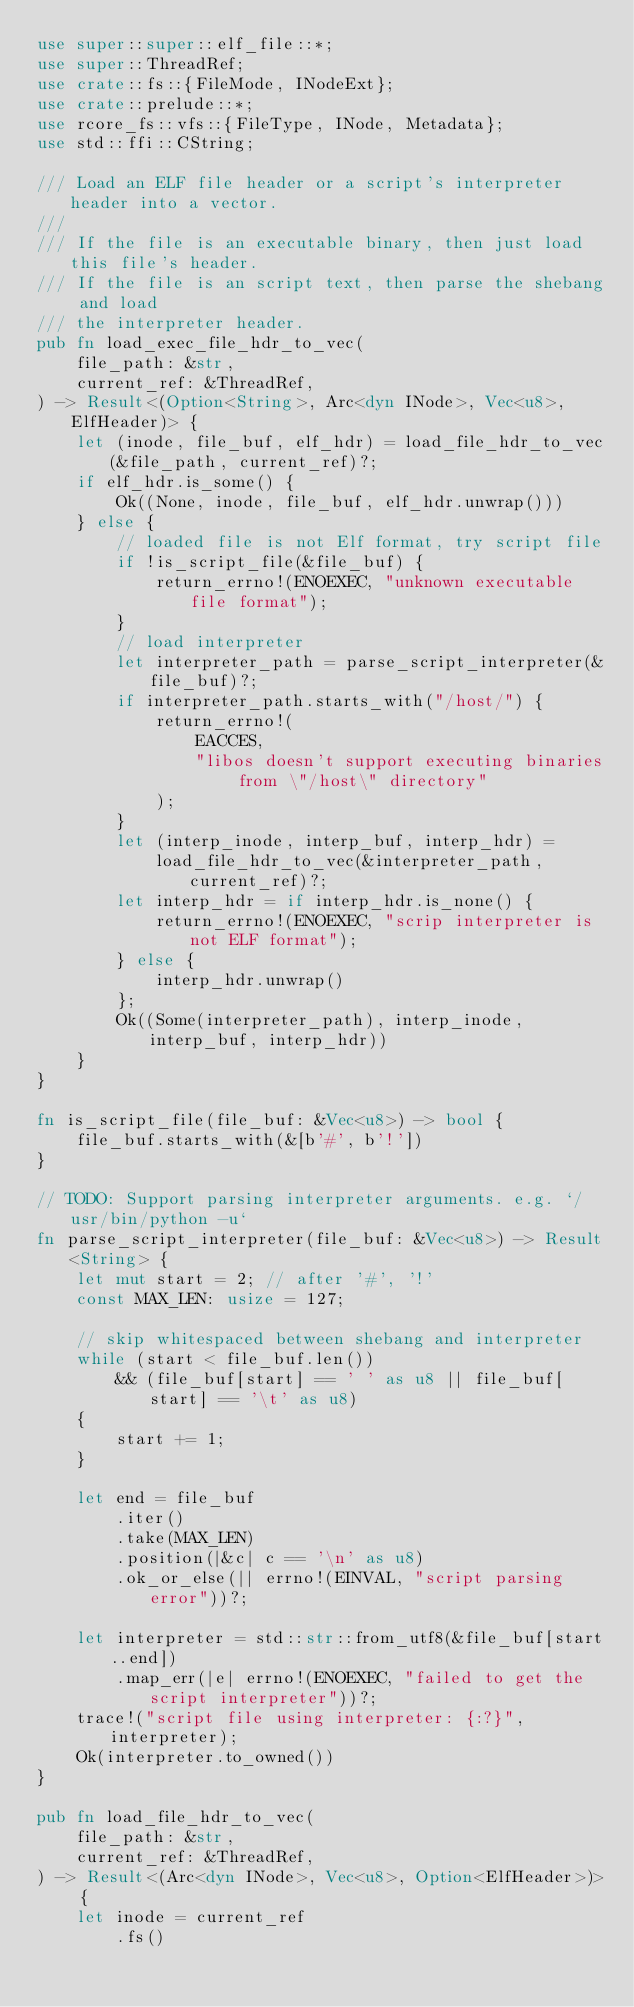Convert code to text. <code><loc_0><loc_0><loc_500><loc_500><_Rust_>use super::super::elf_file::*;
use super::ThreadRef;
use crate::fs::{FileMode, INodeExt};
use crate::prelude::*;
use rcore_fs::vfs::{FileType, INode, Metadata};
use std::ffi::CString;

/// Load an ELF file header or a script's interpreter header into a vector.
///
/// If the file is an executable binary, then just load this file's header.
/// If the file is an script text, then parse the shebang and load
/// the interpreter header.
pub fn load_exec_file_hdr_to_vec(
    file_path: &str,
    current_ref: &ThreadRef,
) -> Result<(Option<String>, Arc<dyn INode>, Vec<u8>, ElfHeader)> {
    let (inode, file_buf, elf_hdr) = load_file_hdr_to_vec(&file_path, current_ref)?;
    if elf_hdr.is_some() {
        Ok((None, inode, file_buf, elf_hdr.unwrap()))
    } else {
        // loaded file is not Elf format, try script file
        if !is_script_file(&file_buf) {
            return_errno!(ENOEXEC, "unknown executable file format");
        }
        // load interpreter
        let interpreter_path = parse_script_interpreter(&file_buf)?;
        if interpreter_path.starts_with("/host/") {
            return_errno!(
                EACCES,
                "libos doesn't support executing binaries from \"/host\" directory"
            );
        }
        let (interp_inode, interp_buf, interp_hdr) =
            load_file_hdr_to_vec(&interpreter_path, current_ref)?;
        let interp_hdr = if interp_hdr.is_none() {
            return_errno!(ENOEXEC, "scrip interpreter is not ELF format");
        } else {
            interp_hdr.unwrap()
        };
        Ok((Some(interpreter_path), interp_inode, interp_buf, interp_hdr))
    }
}

fn is_script_file(file_buf: &Vec<u8>) -> bool {
    file_buf.starts_with(&[b'#', b'!'])
}

// TODO: Support parsing interpreter arguments. e.g. `/usr/bin/python -u`
fn parse_script_interpreter(file_buf: &Vec<u8>) -> Result<String> {
    let mut start = 2; // after '#', '!'
    const MAX_LEN: usize = 127;

    // skip whitespaced between shebang and interpreter
    while (start < file_buf.len())
        && (file_buf[start] == ' ' as u8 || file_buf[start] == '\t' as u8)
    {
        start += 1;
    }

    let end = file_buf
        .iter()
        .take(MAX_LEN)
        .position(|&c| c == '\n' as u8)
        .ok_or_else(|| errno!(EINVAL, "script parsing error"))?;

    let interpreter = std::str::from_utf8(&file_buf[start..end])
        .map_err(|e| errno!(ENOEXEC, "failed to get the script interpreter"))?;
    trace!("script file using interpreter: {:?}", interpreter);
    Ok(interpreter.to_owned())
}

pub fn load_file_hdr_to_vec(
    file_path: &str,
    current_ref: &ThreadRef,
) -> Result<(Arc<dyn INode>, Vec<u8>, Option<ElfHeader>)> {
    let inode = current_ref
        .fs()</code> 